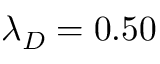<formula> <loc_0><loc_0><loc_500><loc_500>\lambda _ { D } = 0 . 5 0</formula> 